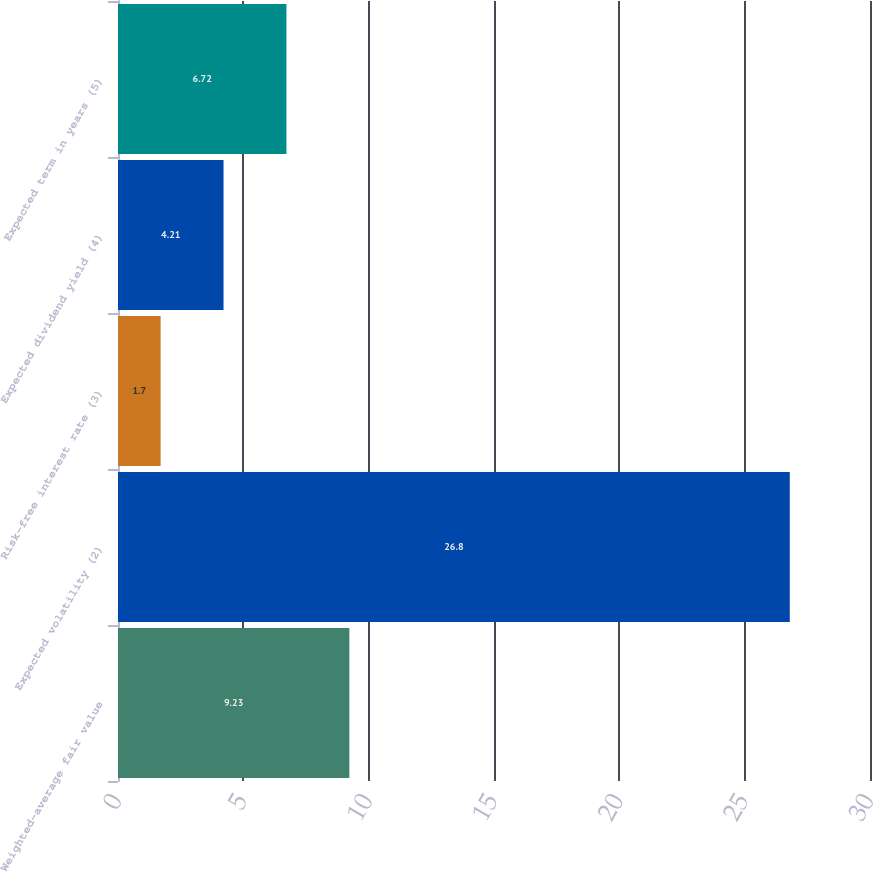Convert chart. <chart><loc_0><loc_0><loc_500><loc_500><bar_chart><fcel>Weighted-average fair value<fcel>Expected volatility (2)<fcel>Risk-free interest rate (3)<fcel>Expected dividend yield (4)<fcel>Expected term in years (5)<nl><fcel>9.23<fcel>26.8<fcel>1.7<fcel>4.21<fcel>6.72<nl></chart> 